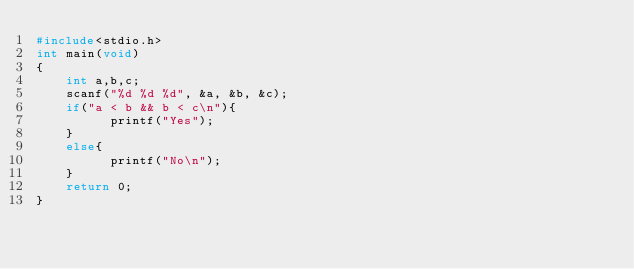Convert code to text. <code><loc_0><loc_0><loc_500><loc_500><_C_>#include<stdio.h>
int main(void)
{
    int a,b,c;
    scanf("%d %d %d", &a, &b, &c);
    if("a < b && b < c\n"){
          printf("Yes");
    }
    else{
          printf("No\n");
    }
    return 0;
}

</code> 